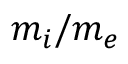<formula> <loc_0><loc_0><loc_500><loc_500>m _ { i } / m _ { e }</formula> 